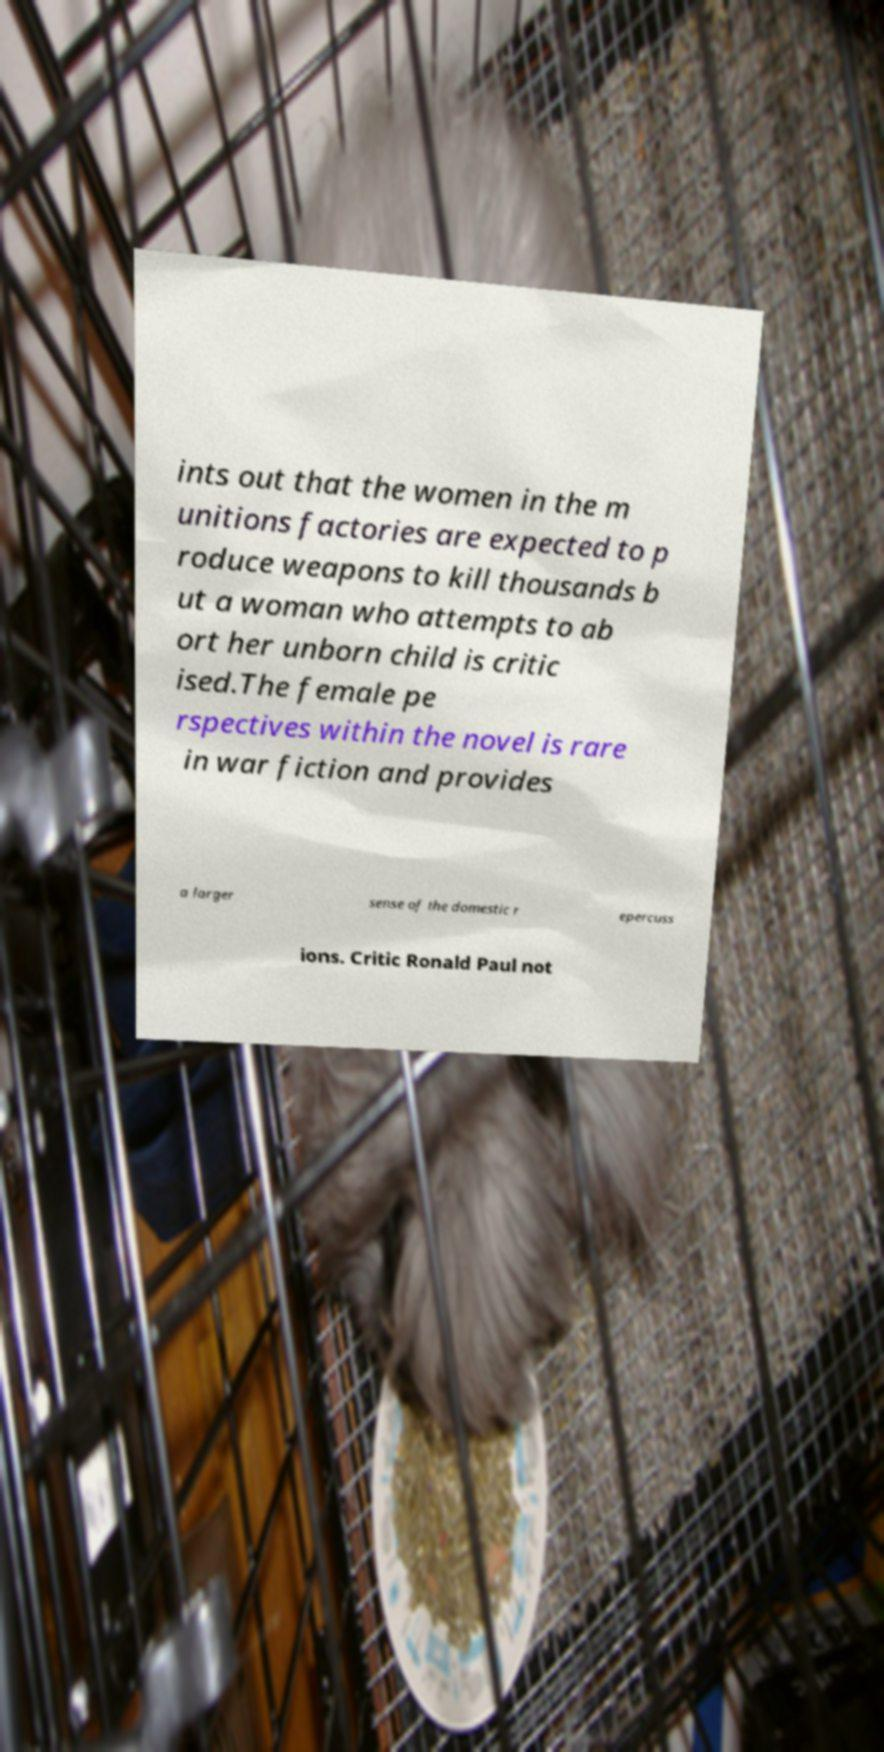What messages or text are displayed in this image? I need them in a readable, typed format. ints out that the women in the m unitions factories are expected to p roduce weapons to kill thousands b ut a woman who attempts to ab ort her unborn child is critic ised.The female pe rspectives within the novel is rare in war fiction and provides a larger sense of the domestic r epercuss ions. Critic Ronald Paul not 